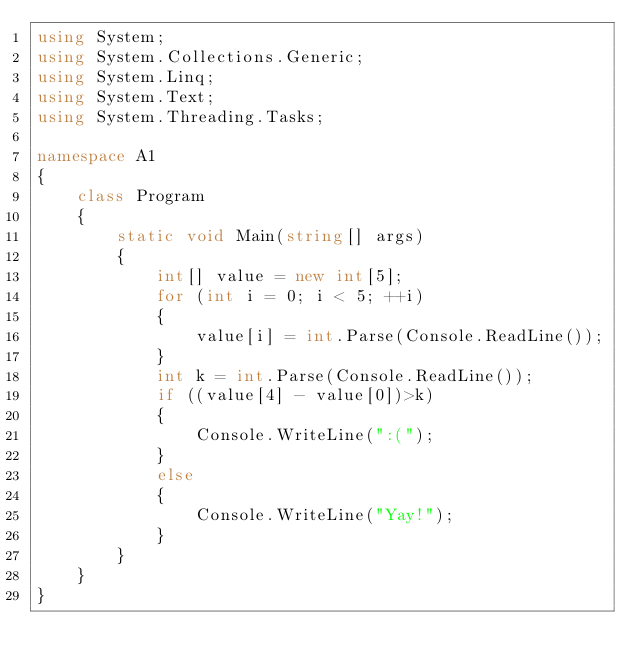<code> <loc_0><loc_0><loc_500><loc_500><_C#_>using System;
using System.Collections.Generic;
using System.Linq;
using System.Text;
using System.Threading.Tasks;

namespace A1
{
    class Program
    {
        static void Main(string[] args)
        {
            int[] value = new int[5];
            for (int i = 0; i < 5; ++i)
            {
                value[i] = int.Parse(Console.ReadLine());
            }
            int k = int.Parse(Console.ReadLine());
            if ((value[4] - value[0])>k)
            {
                Console.WriteLine(":(");
            }
            else
            {
                Console.WriteLine("Yay!");
            }
        }   
    }
}</code> 